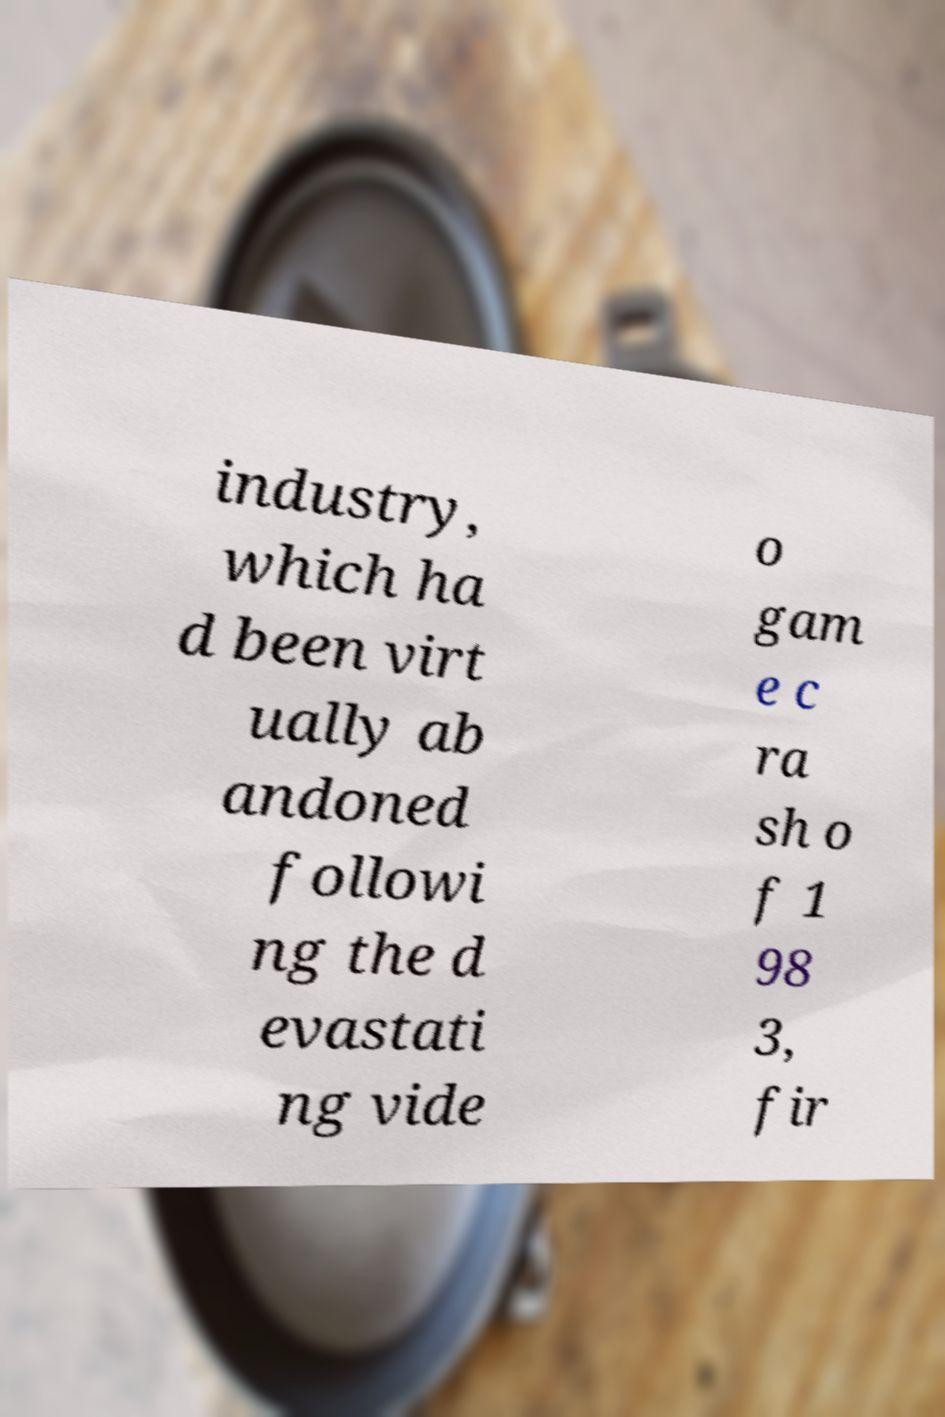Could you assist in decoding the text presented in this image and type it out clearly? industry, which ha d been virt ually ab andoned followi ng the d evastati ng vide o gam e c ra sh o f 1 98 3, fir 